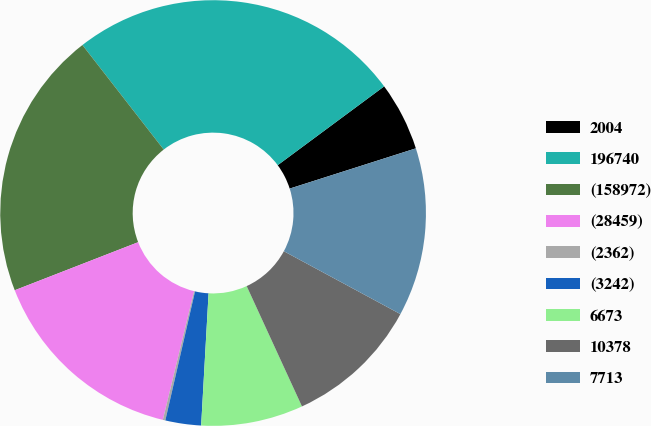Convert chart to OTSL. <chart><loc_0><loc_0><loc_500><loc_500><pie_chart><fcel>2004<fcel>196740<fcel>(158972)<fcel>(28459)<fcel>(2362)<fcel>(3242)<fcel>6673<fcel>10378<fcel>7713<nl><fcel>5.23%<fcel>25.38%<fcel>20.39%<fcel>15.3%<fcel>0.19%<fcel>2.71%<fcel>7.75%<fcel>10.27%<fcel>12.79%<nl></chart> 